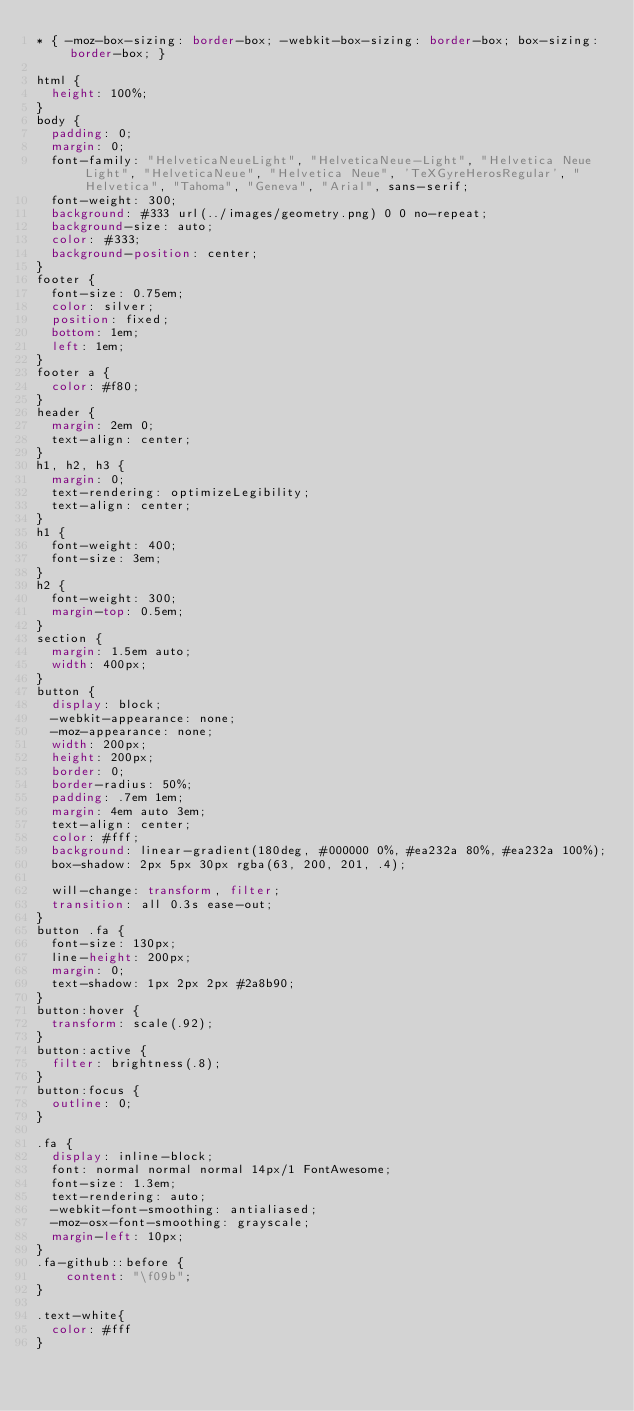<code> <loc_0><loc_0><loc_500><loc_500><_CSS_>* { -moz-box-sizing: border-box; -webkit-box-sizing: border-box; box-sizing: border-box; }

html {
  height: 100%;
}
body {
  padding: 0;
  margin: 0;
  font-family: "HelveticaNeueLight", "HelveticaNeue-Light", "Helvetica Neue Light", "HelveticaNeue", "Helvetica Neue", 'TeXGyreHerosRegular', "Helvetica", "Tahoma", "Geneva", "Arial", sans-serif;
  font-weight: 300;
  background: #333 url(../images/geometry.png) 0 0 no-repeat;
  background-size: auto;
  color: #333;
  background-position: center;
}
footer {
  font-size: 0.75em;
  color: silver;
  position: fixed;
  bottom: 1em;
  left: 1em;
}
footer a {
  color: #f80;
}
header {
  margin: 2em 0;
  text-align: center;
}
h1, h2, h3 {
  margin: 0;
  text-rendering: optimizeLegibility;
  text-align: center;
}
h1 {
  font-weight: 400;
  font-size: 3em;
}
h2 {
  font-weight: 300;
  margin-top: 0.5em;
}
section {
  margin: 1.5em auto;
  width: 400px;
}
button {
  display: block;
  -webkit-appearance: none;
  -moz-appearance: none;
  width: 200px;
  height: 200px;
  border: 0;
  border-radius: 50%;
  padding: .7em 1em;
  margin: 4em auto 3em;
  text-align: center;
  color: #fff;
  background: linear-gradient(180deg, #000000 0%, #ea232a 80%, #ea232a 100%);
  box-shadow: 2px 5px 30px rgba(63, 200, 201, .4);

  will-change: transform, filter;
  transition: all 0.3s ease-out;
}
button .fa {
  font-size: 130px;
  line-height: 200px;
  margin: 0;
  text-shadow: 1px 2px 2px #2a8b90;
}
button:hover {
  transform: scale(.92);
}
button:active {
  filter: brightness(.8);
}
button:focus {
  outline: 0;
}

.fa {
  display: inline-block;
  font: normal normal normal 14px/1 FontAwesome;
  font-size: 1.3em;
  text-rendering: auto;
  -webkit-font-smoothing: antialiased;
  -moz-osx-font-smoothing: grayscale;
  margin-left: 10px;
}
.fa-github::before {
    content: "\f09b";
}

.text-white{
  color: #fff
}</code> 